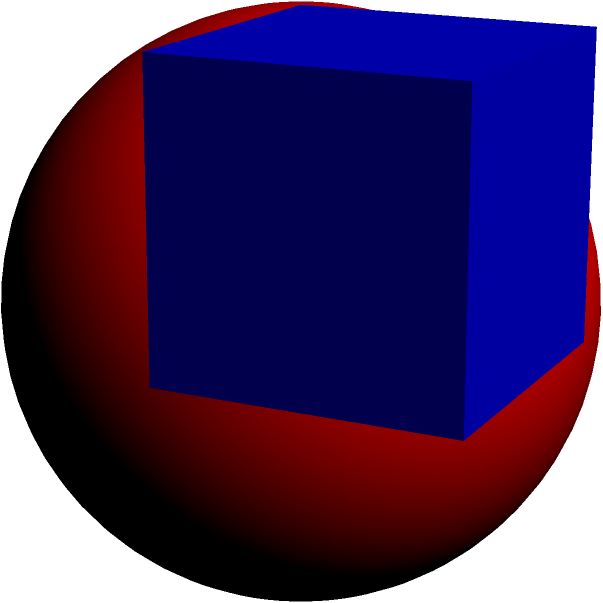In the spirit of fostering intercultural understanding through mathematical concepts, consider a cube with side length 2 units. A sphere is inscribed within this cube, touching all six faces. Calculate the volume of the inscribed sphere, expressing your answer in terms of π. Let's approach this step-by-step:

1) First, we need to understand the relationship between the cube and the inscribed sphere. The diameter of the sphere is equal to the side length of the cube.

2) Given that the cube has a side length of 2 units, the diameter of the sphere is also 2 units.

3) The radius of the sphere is half of its diameter. So, the radius (r) is:
   $r = \frac{2}{2} = 1$ unit

4) The formula for the volume of a sphere is:
   $V = \frac{4}{3}\pi r^3$

5) Substituting our radius value:
   $V = \frac{4}{3}\pi (1)^3 = \frac{4}{3}\pi$

6) This can be simplified to:
   $V = \frac{4\pi}{3}$ cubic units

This problem illustrates how geometric concepts can bridge cultural divides, as the principles of geometry are universal across all cultures and societies.
Answer: $\frac{4\pi}{3}$ cubic units 